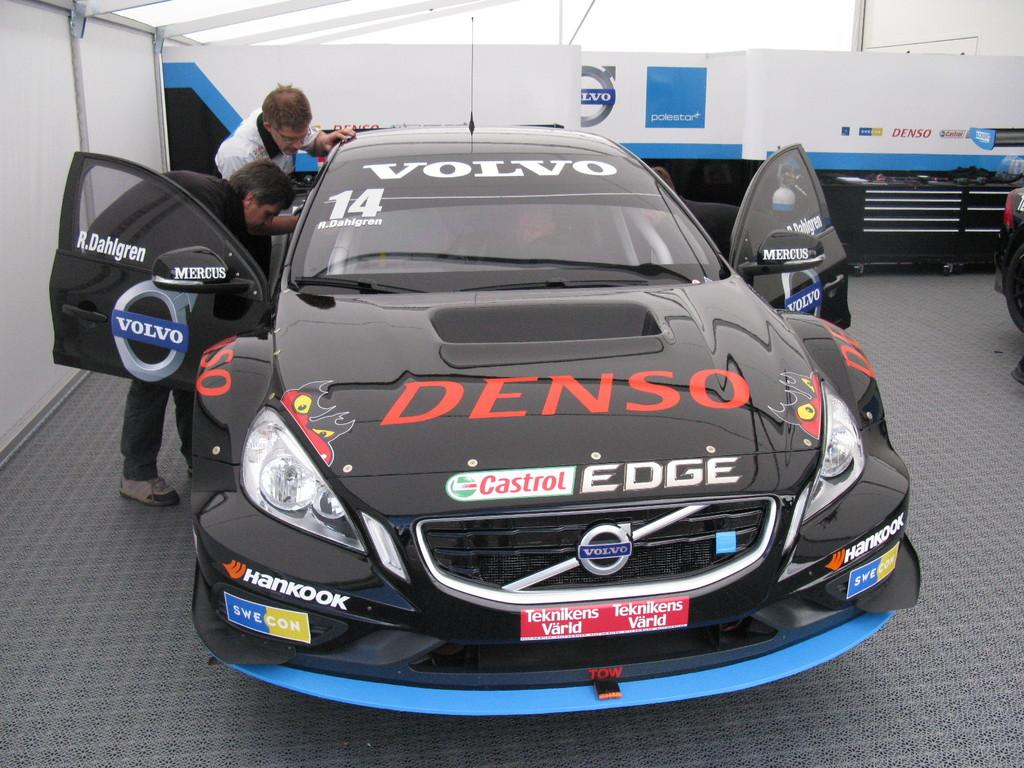What is the main object on the ground in the image? There is a car on the ground in the image. Can you describe the people visible in the image? There are people visible in the image, but their specific characteristics are not mentioned in the facts. What can be seen in the background of the image? There is a wall and an advertisement board in the background of the image, along with other objects. What type of twig is being used as a prop by the sisters in the image? There is no mention of sisters or a twig in the image, so this question cannot be answered definitively. 